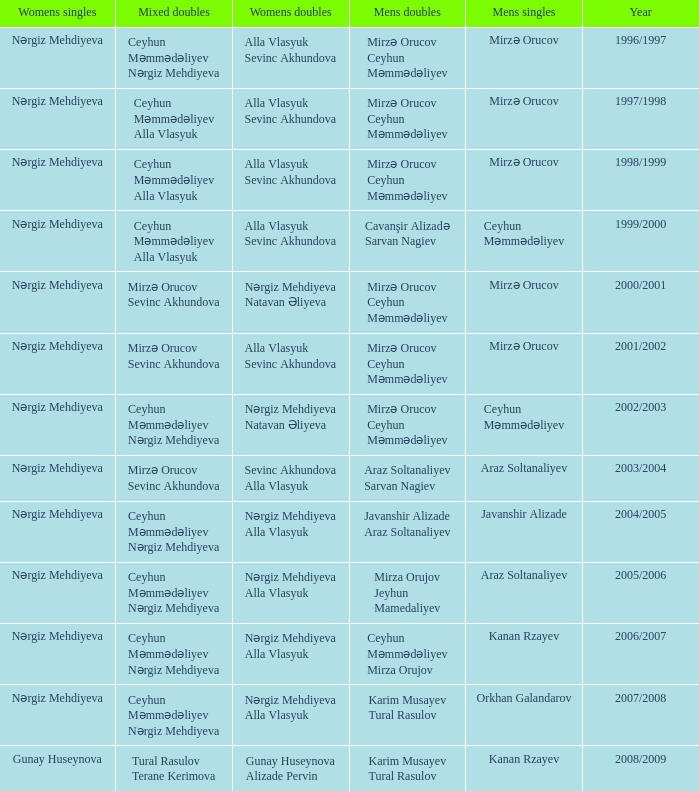Who are all the womens doubles for the year 2008/2009? Gunay Huseynova Alizade Pervin. 